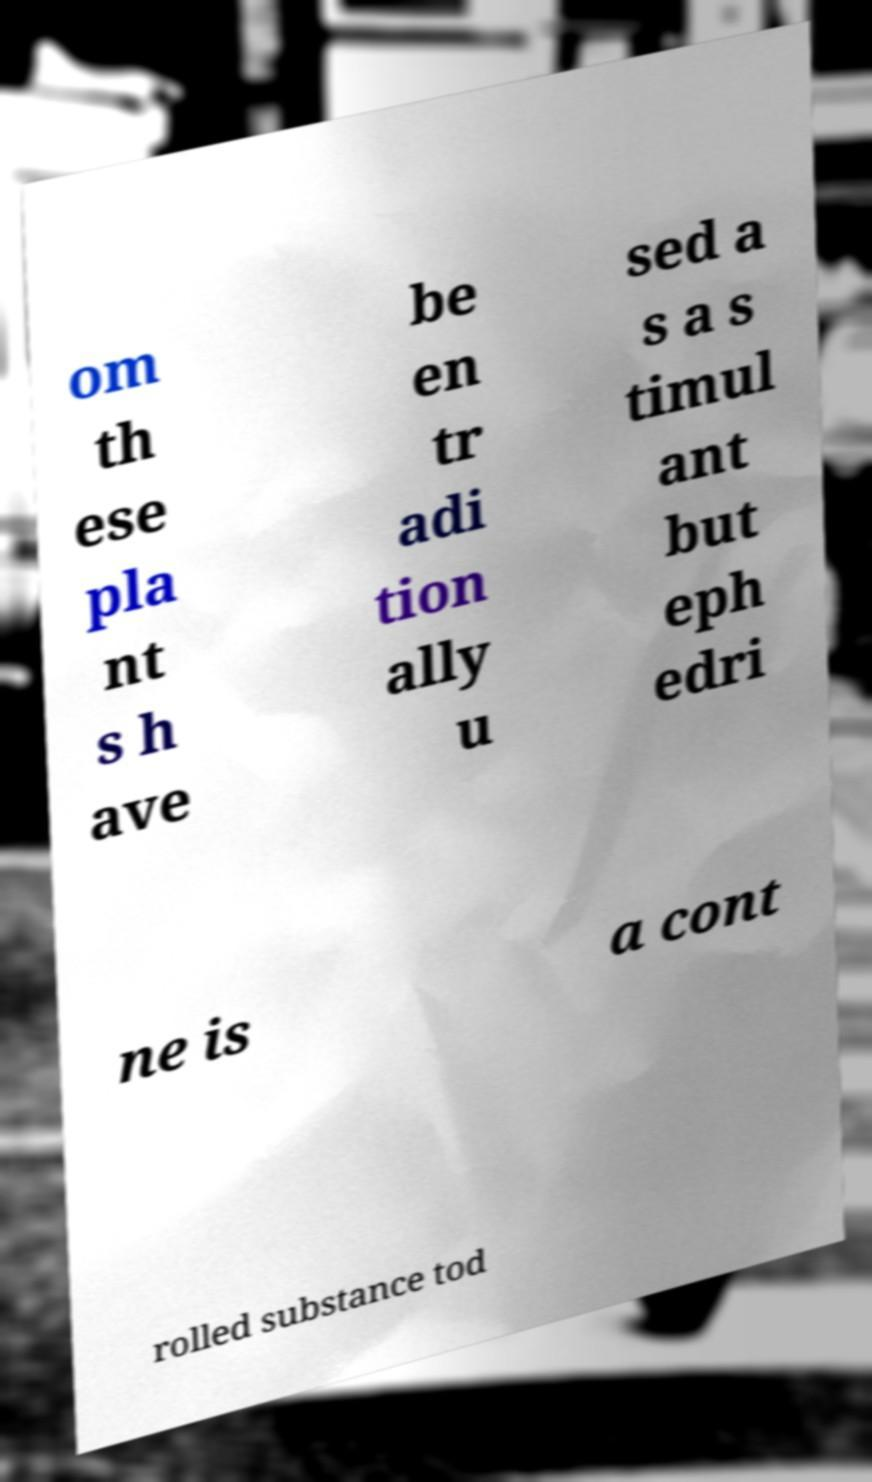Please read and relay the text visible in this image. What does it say? om th ese pla nt s h ave be en tr adi tion ally u sed a s a s timul ant but eph edri ne is a cont rolled substance tod 